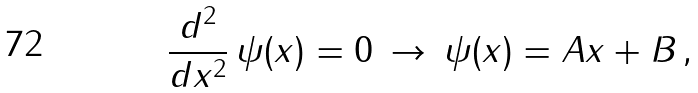<formula> <loc_0><loc_0><loc_500><loc_500>\frac { d ^ { 2 } } { d x ^ { 2 } } \, \psi ( x ) = 0 \, \rightarrow \, \psi ( x ) = A x + B \, ,</formula> 